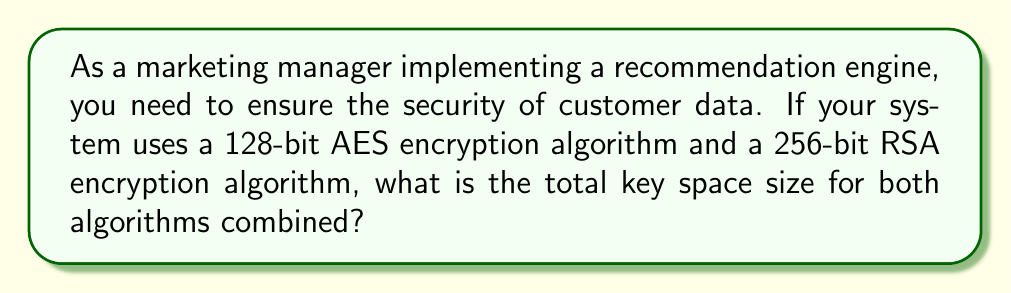What is the answer to this math problem? To solve this problem, we need to calculate the key space size for each algorithm and then combine them:

1. AES-128 key space:
   - AES-128 uses a 128-bit key
   - Key space size = $2^{128}$

2. RSA-256 key space:
   - RSA-256 uses a 256-bit key
   - Key space size = $2^{256}$

3. Total key space:
   - To combine the key spaces, we multiply them together
   - Total key space = $2^{128} \times 2^{256}$
   - Using the laws of exponents: $2^{128} \times 2^{256} = 2^{128+256} = 2^{384}$

Therefore, the total key space size for both algorithms combined is $2^{384}$.
Answer: $2^{384}$ 